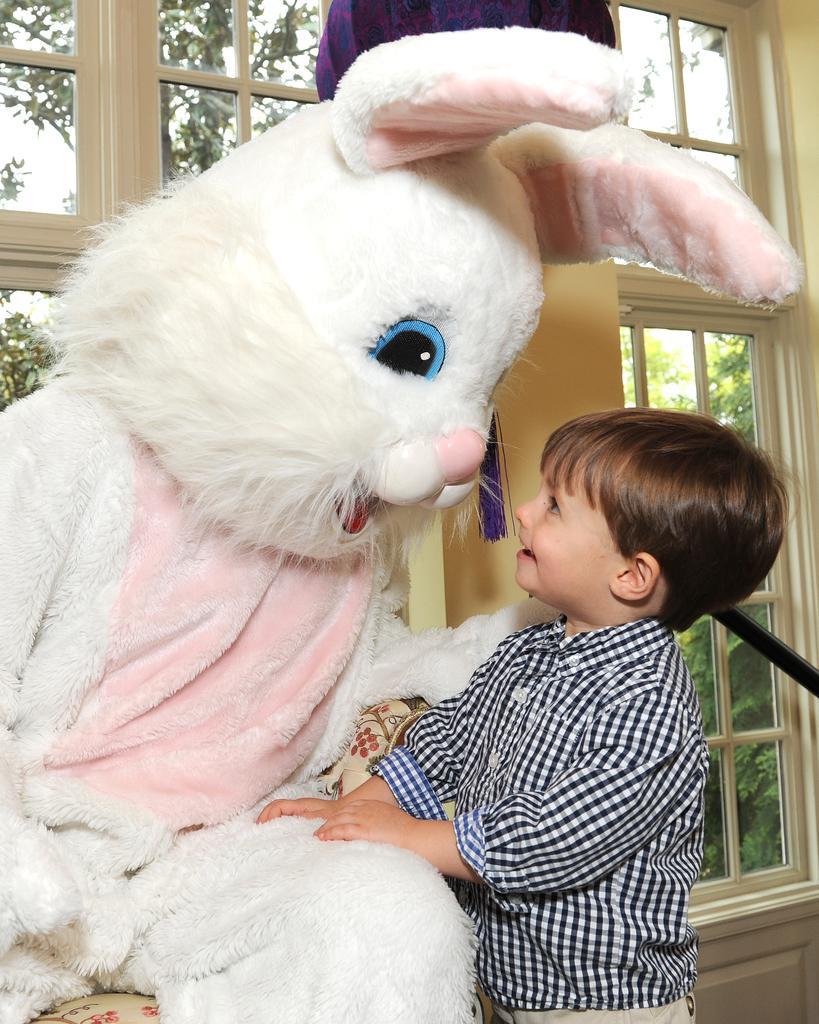Can you describe this image briefly? In the center of the image we can see a kid standing at a toy. In the background there are windows, trees and sky. 